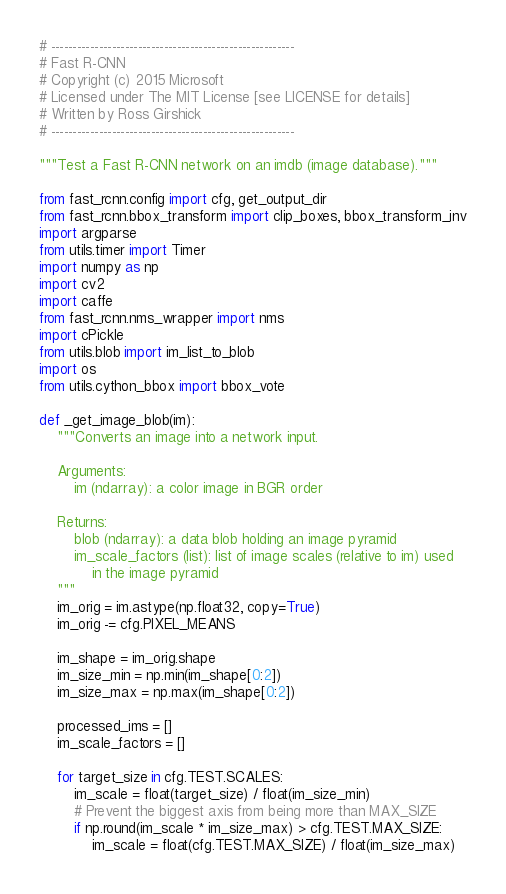<code> <loc_0><loc_0><loc_500><loc_500><_Python_># --------------------------------------------------------
# Fast R-CNN
# Copyright (c) 2015 Microsoft
# Licensed under The MIT License [see LICENSE for details]
# Written by Ross Girshick
# --------------------------------------------------------

"""Test a Fast R-CNN network on an imdb (image database)."""

from fast_rcnn.config import cfg, get_output_dir
from fast_rcnn.bbox_transform import clip_boxes, bbox_transform_inv
import argparse
from utils.timer import Timer
import numpy as np
import cv2
import caffe
from fast_rcnn.nms_wrapper import nms
import cPickle
from utils.blob import im_list_to_blob
import os
from utils.cython_bbox import bbox_vote

def _get_image_blob(im):
    """Converts an image into a network input.

    Arguments:
        im (ndarray): a color image in BGR order

    Returns:
        blob (ndarray): a data blob holding an image pyramid
        im_scale_factors (list): list of image scales (relative to im) used
            in the image pyramid
    """
    im_orig = im.astype(np.float32, copy=True)
    im_orig -= cfg.PIXEL_MEANS

    im_shape = im_orig.shape
    im_size_min = np.min(im_shape[0:2])
    im_size_max = np.max(im_shape[0:2])

    processed_ims = []
    im_scale_factors = []

    for target_size in cfg.TEST.SCALES:
        im_scale = float(target_size) / float(im_size_min)
        # Prevent the biggest axis from being more than MAX_SIZE
        if np.round(im_scale * im_size_max) > cfg.TEST.MAX_SIZE:
            im_scale = float(cfg.TEST.MAX_SIZE) / float(im_size_max)
</code> 